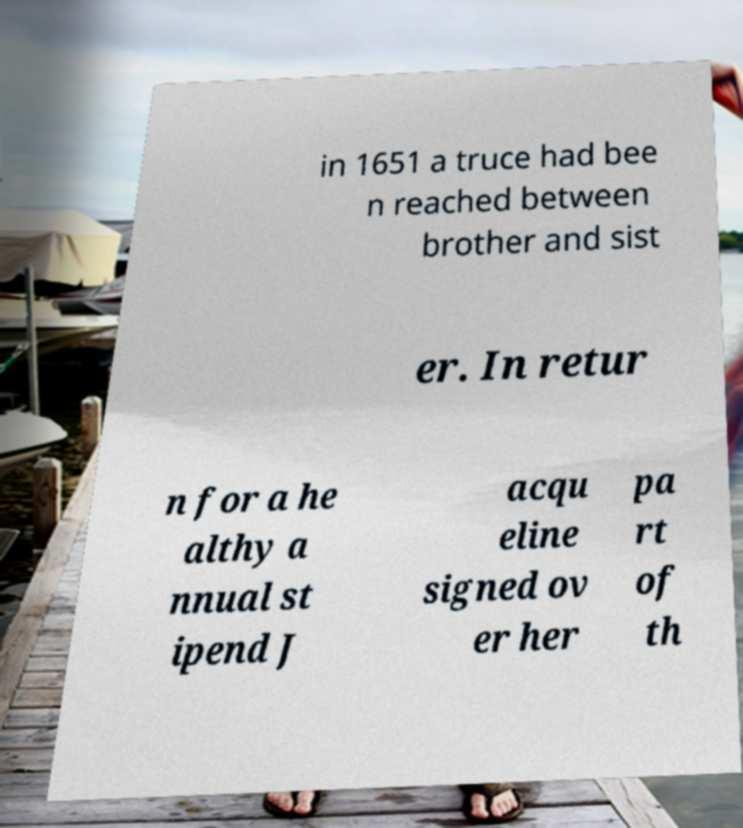For documentation purposes, I need the text within this image transcribed. Could you provide that? in 1651 a truce had bee n reached between brother and sist er. In retur n for a he althy a nnual st ipend J acqu eline signed ov er her pa rt of th 